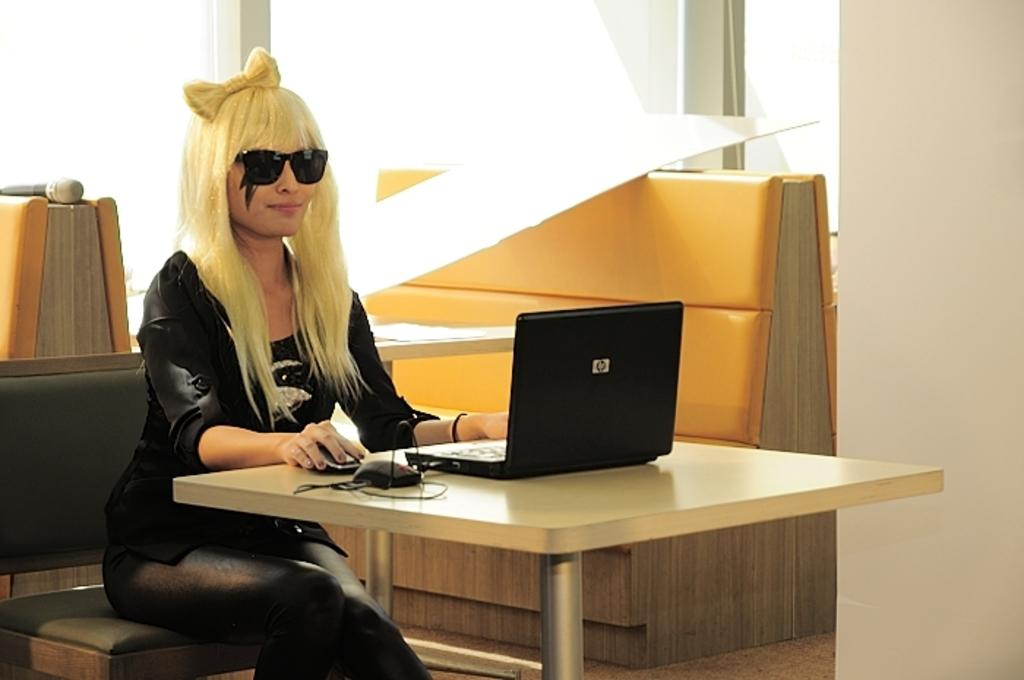Who is the main subject in the image? There is a woman in the image. What is the woman doing in the image? The woman is sitting in a chair and working on a laptop. What is the woman wearing in the image? The woman is wearing a black dress. What type of feather can be seen on the wall in the image? There is no feather or wall present in the image; it features a woman sitting in a chair and working on a laptop. What kind of fowl is visible in the image? There is no fowl present in the image. 